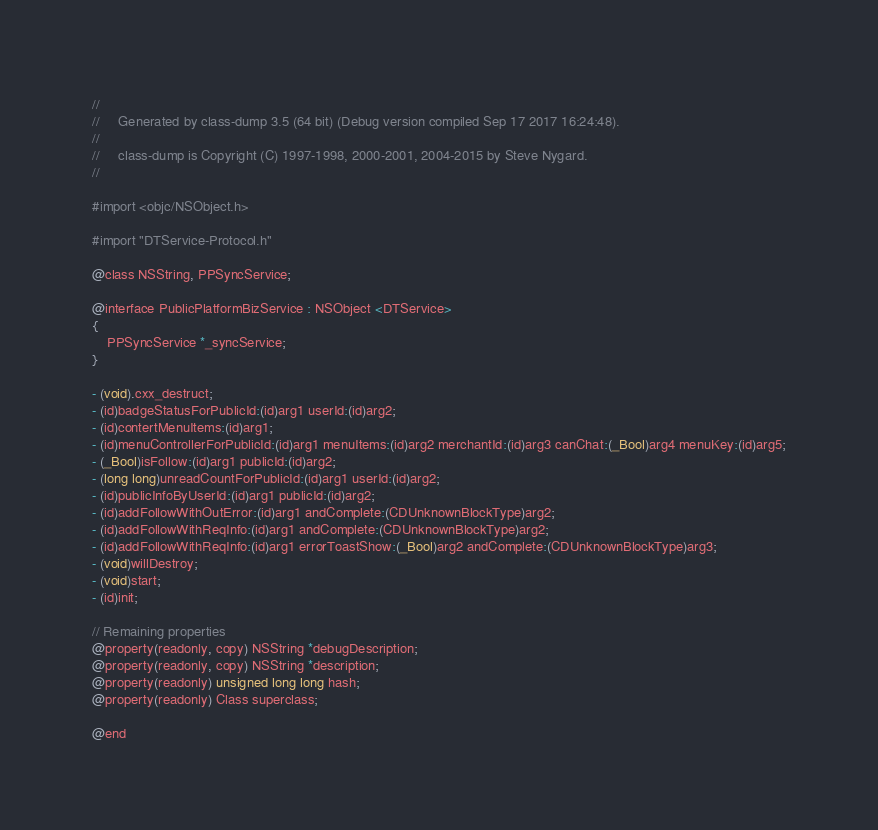<code> <loc_0><loc_0><loc_500><loc_500><_C_>//
//     Generated by class-dump 3.5 (64 bit) (Debug version compiled Sep 17 2017 16:24:48).
//
//     class-dump is Copyright (C) 1997-1998, 2000-2001, 2004-2015 by Steve Nygard.
//

#import <objc/NSObject.h>

#import "DTService-Protocol.h"

@class NSString, PPSyncService;

@interface PublicPlatformBizService : NSObject <DTService>
{
    PPSyncService *_syncService;
}

- (void).cxx_destruct;
- (id)badgeStatusForPublicId:(id)arg1 userId:(id)arg2;
- (id)contertMenuItems:(id)arg1;
- (id)menuControllerForPublicId:(id)arg1 menuItems:(id)arg2 merchantId:(id)arg3 canChat:(_Bool)arg4 menuKey:(id)arg5;
- (_Bool)isFollow:(id)arg1 publicId:(id)arg2;
- (long long)unreadCountForPublicId:(id)arg1 userId:(id)arg2;
- (id)publicInfoByUserId:(id)arg1 publicId:(id)arg2;
- (id)addFollowWithOutError:(id)arg1 andComplete:(CDUnknownBlockType)arg2;
- (id)addFollowWithReqInfo:(id)arg1 andComplete:(CDUnknownBlockType)arg2;
- (id)addFollowWithReqInfo:(id)arg1 errorToastShow:(_Bool)arg2 andComplete:(CDUnknownBlockType)arg3;
- (void)willDestroy;
- (void)start;
- (id)init;

// Remaining properties
@property(readonly, copy) NSString *debugDescription;
@property(readonly, copy) NSString *description;
@property(readonly) unsigned long long hash;
@property(readonly) Class superclass;

@end

</code> 